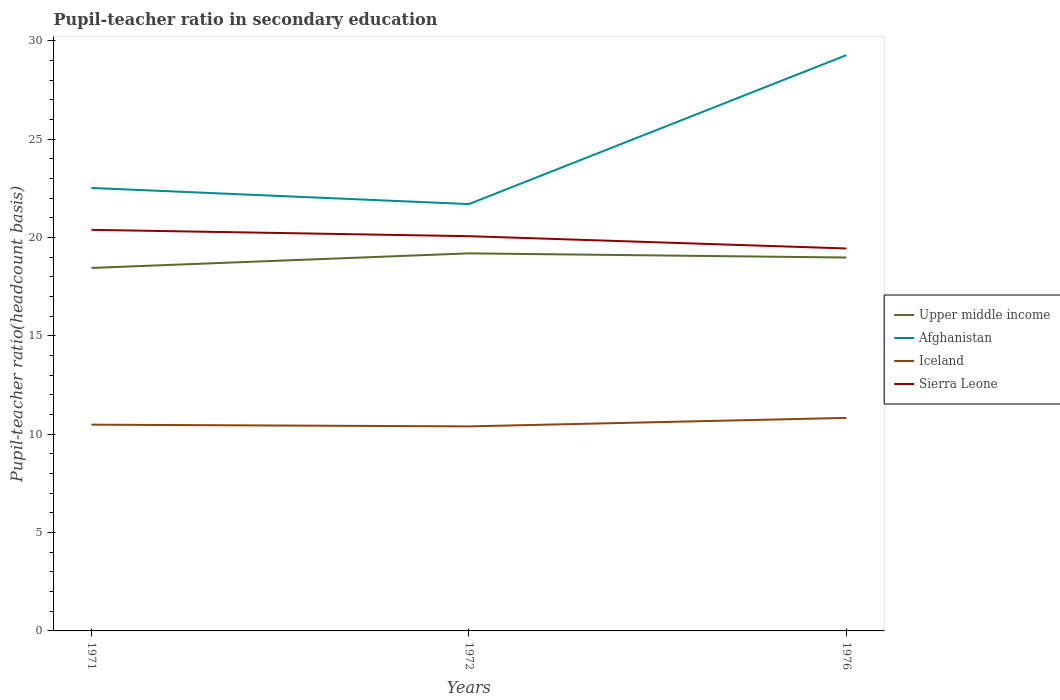Across all years, what is the maximum pupil-teacher ratio in secondary education in Afghanistan?
Keep it short and to the point. 21.7. In which year was the pupil-teacher ratio in secondary education in Sierra Leone maximum?
Offer a terse response. 1976. What is the total pupil-teacher ratio in secondary education in Afghanistan in the graph?
Offer a very short reply. -7.57. What is the difference between the highest and the second highest pupil-teacher ratio in secondary education in Afghanistan?
Offer a terse response. 7.57. How many lines are there?
Ensure brevity in your answer.  4. Does the graph contain any zero values?
Your response must be concise. No. Where does the legend appear in the graph?
Give a very brief answer. Center right. How many legend labels are there?
Your answer should be very brief. 4. What is the title of the graph?
Provide a short and direct response. Pupil-teacher ratio in secondary education. What is the label or title of the X-axis?
Make the answer very short. Years. What is the label or title of the Y-axis?
Your answer should be very brief. Pupil-teacher ratio(headcount basis). What is the Pupil-teacher ratio(headcount basis) in Upper middle income in 1971?
Give a very brief answer. 18.46. What is the Pupil-teacher ratio(headcount basis) in Afghanistan in 1971?
Give a very brief answer. 22.52. What is the Pupil-teacher ratio(headcount basis) in Iceland in 1971?
Give a very brief answer. 10.49. What is the Pupil-teacher ratio(headcount basis) of Sierra Leone in 1971?
Make the answer very short. 20.39. What is the Pupil-teacher ratio(headcount basis) in Upper middle income in 1972?
Provide a succinct answer. 19.2. What is the Pupil-teacher ratio(headcount basis) of Afghanistan in 1972?
Your answer should be compact. 21.7. What is the Pupil-teacher ratio(headcount basis) of Iceland in 1972?
Offer a terse response. 10.4. What is the Pupil-teacher ratio(headcount basis) of Sierra Leone in 1972?
Ensure brevity in your answer.  20.07. What is the Pupil-teacher ratio(headcount basis) of Upper middle income in 1976?
Keep it short and to the point. 18.98. What is the Pupil-teacher ratio(headcount basis) in Afghanistan in 1976?
Provide a succinct answer. 29.27. What is the Pupil-teacher ratio(headcount basis) of Iceland in 1976?
Ensure brevity in your answer.  10.83. What is the Pupil-teacher ratio(headcount basis) in Sierra Leone in 1976?
Offer a very short reply. 19.44. Across all years, what is the maximum Pupil-teacher ratio(headcount basis) of Upper middle income?
Offer a terse response. 19.2. Across all years, what is the maximum Pupil-teacher ratio(headcount basis) in Afghanistan?
Give a very brief answer. 29.27. Across all years, what is the maximum Pupil-teacher ratio(headcount basis) in Iceland?
Provide a short and direct response. 10.83. Across all years, what is the maximum Pupil-teacher ratio(headcount basis) in Sierra Leone?
Provide a short and direct response. 20.39. Across all years, what is the minimum Pupil-teacher ratio(headcount basis) in Upper middle income?
Ensure brevity in your answer.  18.46. Across all years, what is the minimum Pupil-teacher ratio(headcount basis) of Afghanistan?
Ensure brevity in your answer.  21.7. Across all years, what is the minimum Pupil-teacher ratio(headcount basis) in Iceland?
Provide a short and direct response. 10.4. Across all years, what is the minimum Pupil-teacher ratio(headcount basis) of Sierra Leone?
Give a very brief answer. 19.44. What is the total Pupil-teacher ratio(headcount basis) in Upper middle income in the graph?
Keep it short and to the point. 56.64. What is the total Pupil-teacher ratio(headcount basis) of Afghanistan in the graph?
Keep it short and to the point. 73.5. What is the total Pupil-teacher ratio(headcount basis) of Iceland in the graph?
Offer a terse response. 31.72. What is the total Pupil-teacher ratio(headcount basis) in Sierra Leone in the graph?
Provide a short and direct response. 59.91. What is the difference between the Pupil-teacher ratio(headcount basis) in Upper middle income in 1971 and that in 1972?
Offer a very short reply. -0.74. What is the difference between the Pupil-teacher ratio(headcount basis) of Afghanistan in 1971 and that in 1972?
Provide a succinct answer. 0.82. What is the difference between the Pupil-teacher ratio(headcount basis) of Iceland in 1971 and that in 1972?
Your response must be concise. 0.09. What is the difference between the Pupil-teacher ratio(headcount basis) of Sierra Leone in 1971 and that in 1972?
Your answer should be compact. 0.32. What is the difference between the Pupil-teacher ratio(headcount basis) of Upper middle income in 1971 and that in 1976?
Your answer should be compact. -0.53. What is the difference between the Pupil-teacher ratio(headcount basis) of Afghanistan in 1971 and that in 1976?
Provide a succinct answer. -6.75. What is the difference between the Pupil-teacher ratio(headcount basis) of Iceland in 1971 and that in 1976?
Offer a terse response. -0.34. What is the difference between the Pupil-teacher ratio(headcount basis) in Sierra Leone in 1971 and that in 1976?
Give a very brief answer. 0.95. What is the difference between the Pupil-teacher ratio(headcount basis) of Upper middle income in 1972 and that in 1976?
Keep it short and to the point. 0.21. What is the difference between the Pupil-teacher ratio(headcount basis) of Afghanistan in 1972 and that in 1976?
Give a very brief answer. -7.57. What is the difference between the Pupil-teacher ratio(headcount basis) of Iceland in 1972 and that in 1976?
Offer a very short reply. -0.43. What is the difference between the Pupil-teacher ratio(headcount basis) in Sierra Leone in 1972 and that in 1976?
Your response must be concise. 0.62. What is the difference between the Pupil-teacher ratio(headcount basis) in Upper middle income in 1971 and the Pupil-teacher ratio(headcount basis) in Afghanistan in 1972?
Provide a short and direct response. -3.25. What is the difference between the Pupil-teacher ratio(headcount basis) of Upper middle income in 1971 and the Pupil-teacher ratio(headcount basis) of Iceland in 1972?
Offer a very short reply. 8.06. What is the difference between the Pupil-teacher ratio(headcount basis) in Upper middle income in 1971 and the Pupil-teacher ratio(headcount basis) in Sierra Leone in 1972?
Give a very brief answer. -1.61. What is the difference between the Pupil-teacher ratio(headcount basis) in Afghanistan in 1971 and the Pupil-teacher ratio(headcount basis) in Iceland in 1972?
Keep it short and to the point. 12.12. What is the difference between the Pupil-teacher ratio(headcount basis) in Afghanistan in 1971 and the Pupil-teacher ratio(headcount basis) in Sierra Leone in 1972?
Offer a very short reply. 2.45. What is the difference between the Pupil-teacher ratio(headcount basis) of Iceland in 1971 and the Pupil-teacher ratio(headcount basis) of Sierra Leone in 1972?
Make the answer very short. -9.58. What is the difference between the Pupil-teacher ratio(headcount basis) of Upper middle income in 1971 and the Pupil-teacher ratio(headcount basis) of Afghanistan in 1976?
Give a very brief answer. -10.82. What is the difference between the Pupil-teacher ratio(headcount basis) in Upper middle income in 1971 and the Pupil-teacher ratio(headcount basis) in Iceland in 1976?
Offer a terse response. 7.62. What is the difference between the Pupil-teacher ratio(headcount basis) in Upper middle income in 1971 and the Pupil-teacher ratio(headcount basis) in Sierra Leone in 1976?
Provide a succinct answer. -0.99. What is the difference between the Pupil-teacher ratio(headcount basis) of Afghanistan in 1971 and the Pupil-teacher ratio(headcount basis) of Iceland in 1976?
Make the answer very short. 11.69. What is the difference between the Pupil-teacher ratio(headcount basis) of Afghanistan in 1971 and the Pupil-teacher ratio(headcount basis) of Sierra Leone in 1976?
Give a very brief answer. 3.08. What is the difference between the Pupil-teacher ratio(headcount basis) of Iceland in 1971 and the Pupil-teacher ratio(headcount basis) of Sierra Leone in 1976?
Offer a very short reply. -8.96. What is the difference between the Pupil-teacher ratio(headcount basis) of Upper middle income in 1972 and the Pupil-teacher ratio(headcount basis) of Afghanistan in 1976?
Keep it short and to the point. -10.08. What is the difference between the Pupil-teacher ratio(headcount basis) of Upper middle income in 1972 and the Pupil-teacher ratio(headcount basis) of Iceland in 1976?
Your answer should be compact. 8.37. What is the difference between the Pupil-teacher ratio(headcount basis) of Upper middle income in 1972 and the Pupil-teacher ratio(headcount basis) of Sierra Leone in 1976?
Give a very brief answer. -0.25. What is the difference between the Pupil-teacher ratio(headcount basis) of Afghanistan in 1972 and the Pupil-teacher ratio(headcount basis) of Iceland in 1976?
Your answer should be compact. 10.87. What is the difference between the Pupil-teacher ratio(headcount basis) of Afghanistan in 1972 and the Pupil-teacher ratio(headcount basis) of Sierra Leone in 1976?
Give a very brief answer. 2.26. What is the difference between the Pupil-teacher ratio(headcount basis) in Iceland in 1972 and the Pupil-teacher ratio(headcount basis) in Sierra Leone in 1976?
Offer a terse response. -9.05. What is the average Pupil-teacher ratio(headcount basis) in Upper middle income per year?
Provide a succinct answer. 18.88. What is the average Pupil-teacher ratio(headcount basis) of Afghanistan per year?
Your answer should be very brief. 24.5. What is the average Pupil-teacher ratio(headcount basis) of Iceland per year?
Give a very brief answer. 10.57. What is the average Pupil-teacher ratio(headcount basis) in Sierra Leone per year?
Offer a terse response. 19.97. In the year 1971, what is the difference between the Pupil-teacher ratio(headcount basis) in Upper middle income and Pupil-teacher ratio(headcount basis) in Afghanistan?
Provide a succinct answer. -4.07. In the year 1971, what is the difference between the Pupil-teacher ratio(headcount basis) in Upper middle income and Pupil-teacher ratio(headcount basis) in Iceland?
Your answer should be compact. 7.97. In the year 1971, what is the difference between the Pupil-teacher ratio(headcount basis) of Upper middle income and Pupil-teacher ratio(headcount basis) of Sierra Leone?
Your response must be concise. -1.94. In the year 1971, what is the difference between the Pupil-teacher ratio(headcount basis) of Afghanistan and Pupil-teacher ratio(headcount basis) of Iceland?
Keep it short and to the point. 12.03. In the year 1971, what is the difference between the Pupil-teacher ratio(headcount basis) of Afghanistan and Pupil-teacher ratio(headcount basis) of Sierra Leone?
Keep it short and to the point. 2.13. In the year 1971, what is the difference between the Pupil-teacher ratio(headcount basis) in Iceland and Pupil-teacher ratio(headcount basis) in Sierra Leone?
Give a very brief answer. -9.91. In the year 1972, what is the difference between the Pupil-teacher ratio(headcount basis) in Upper middle income and Pupil-teacher ratio(headcount basis) in Afghanistan?
Ensure brevity in your answer.  -2.51. In the year 1972, what is the difference between the Pupil-teacher ratio(headcount basis) of Upper middle income and Pupil-teacher ratio(headcount basis) of Iceland?
Ensure brevity in your answer.  8.8. In the year 1972, what is the difference between the Pupil-teacher ratio(headcount basis) of Upper middle income and Pupil-teacher ratio(headcount basis) of Sierra Leone?
Give a very brief answer. -0.87. In the year 1972, what is the difference between the Pupil-teacher ratio(headcount basis) in Afghanistan and Pupil-teacher ratio(headcount basis) in Iceland?
Your response must be concise. 11.3. In the year 1972, what is the difference between the Pupil-teacher ratio(headcount basis) of Afghanistan and Pupil-teacher ratio(headcount basis) of Sierra Leone?
Give a very brief answer. 1.63. In the year 1972, what is the difference between the Pupil-teacher ratio(headcount basis) of Iceland and Pupil-teacher ratio(headcount basis) of Sierra Leone?
Offer a very short reply. -9.67. In the year 1976, what is the difference between the Pupil-teacher ratio(headcount basis) in Upper middle income and Pupil-teacher ratio(headcount basis) in Afghanistan?
Provide a succinct answer. -10.29. In the year 1976, what is the difference between the Pupil-teacher ratio(headcount basis) of Upper middle income and Pupil-teacher ratio(headcount basis) of Iceland?
Provide a succinct answer. 8.15. In the year 1976, what is the difference between the Pupil-teacher ratio(headcount basis) in Upper middle income and Pupil-teacher ratio(headcount basis) in Sierra Leone?
Your answer should be very brief. -0.46. In the year 1976, what is the difference between the Pupil-teacher ratio(headcount basis) of Afghanistan and Pupil-teacher ratio(headcount basis) of Iceland?
Ensure brevity in your answer.  18.44. In the year 1976, what is the difference between the Pupil-teacher ratio(headcount basis) in Afghanistan and Pupil-teacher ratio(headcount basis) in Sierra Leone?
Provide a short and direct response. 9.83. In the year 1976, what is the difference between the Pupil-teacher ratio(headcount basis) in Iceland and Pupil-teacher ratio(headcount basis) in Sierra Leone?
Ensure brevity in your answer.  -8.61. What is the ratio of the Pupil-teacher ratio(headcount basis) of Upper middle income in 1971 to that in 1972?
Offer a terse response. 0.96. What is the ratio of the Pupil-teacher ratio(headcount basis) of Afghanistan in 1971 to that in 1972?
Make the answer very short. 1.04. What is the ratio of the Pupil-teacher ratio(headcount basis) of Iceland in 1971 to that in 1972?
Ensure brevity in your answer.  1.01. What is the ratio of the Pupil-teacher ratio(headcount basis) in Sierra Leone in 1971 to that in 1972?
Make the answer very short. 1.02. What is the ratio of the Pupil-teacher ratio(headcount basis) of Upper middle income in 1971 to that in 1976?
Your answer should be very brief. 0.97. What is the ratio of the Pupil-teacher ratio(headcount basis) of Afghanistan in 1971 to that in 1976?
Keep it short and to the point. 0.77. What is the ratio of the Pupil-teacher ratio(headcount basis) in Iceland in 1971 to that in 1976?
Ensure brevity in your answer.  0.97. What is the ratio of the Pupil-teacher ratio(headcount basis) of Sierra Leone in 1971 to that in 1976?
Make the answer very short. 1.05. What is the ratio of the Pupil-teacher ratio(headcount basis) of Upper middle income in 1972 to that in 1976?
Provide a short and direct response. 1.01. What is the ratio of the Pupil-teacher ratio(headcount basis) in Afghanistan in 1972 to that in 1976?
Provide a succinct answer. 0.74. What is the ratio of the Pupil-teacher ratio(headcount basis) in Iceland in 1972 to that in 1976?
Your response must be concise. 0.96. What is the ratio of the Pupil-teacher ratio(headcount basis) in Sierra Leone in 1972 to that in 1976?
Make the answer very short. 1.03. What is the difference between the highest and the second highest Pupil-teacher ratio(headcount basis) in Upper middle income?
Offer a very short reply. 0.21. What is the difference between the highest and the second highest Pupil-teacher ratio(headcount basis) in Afghanistan?
Provide a succinct answer. 6.75. What is the difference between the highest and the second highest Pupil-teacher ratio(headcount basis) of Iceland?
Ensure brevity in your answer.  0.34. What is the difference between the highest and the second highest Pupil-teacher ratio(headcount basis) of Sierra Leone?
Give a very brief answer. 0.32. What is the difference between the highest and the lowest Pupil-teacher ratio(headcount basis) in Upper middle income?
Offer a terse response. 0.74. What is the difference between the highest and the lowest Pupil-teacher ratio(headcount basis) in Afghanistan?
Make the answer very short. 7.57. What is the difference between the highest and the lowest Pupil-teacher ratio(headcount basis) of Iceland?
Keep it short and to the point. 0.43. What is the difference between the highest and the lowest Pupil-teacher ratio(headcount basis) in Sierra Leone?
Offer a very short reply. 0.95. 